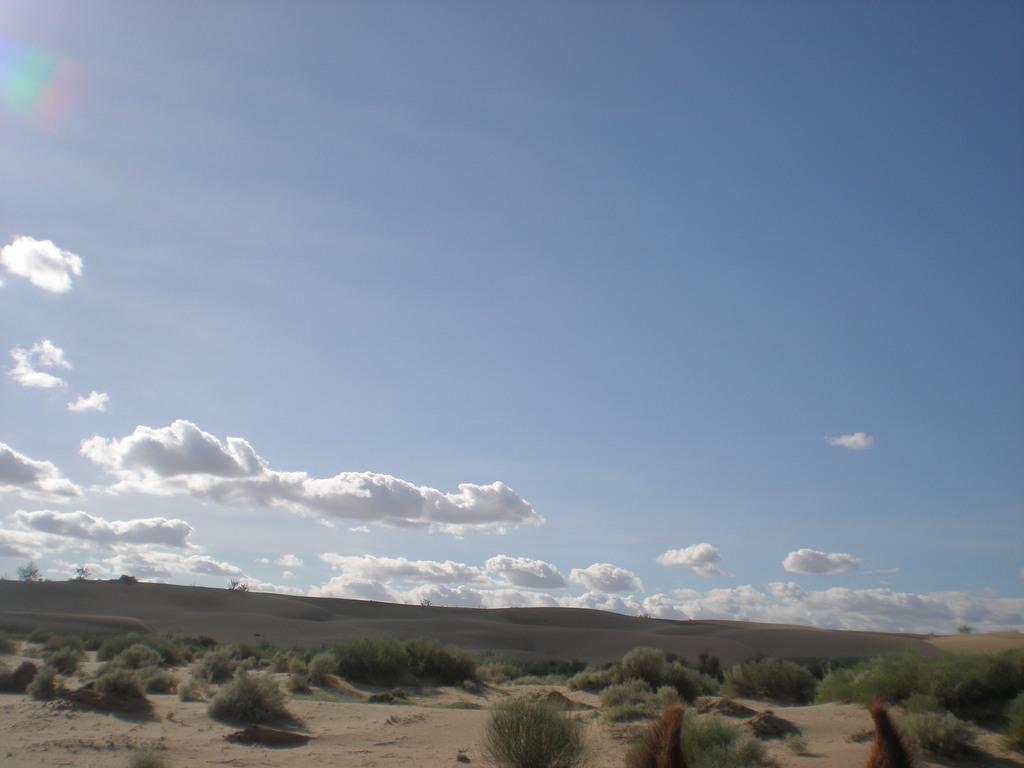How would you summarize this image in a sentence or two? In this image I can see few plants in green color. In the background the sky is in blue and white color. 